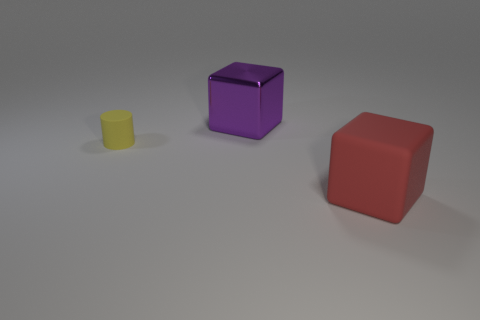Add 1 large metallic objects. How many objects exist? 4 Subtract all cylinders. How many objects are left? 2 Add 2 small yellow rubber things. How many small yellow rubber things are left? 3 Add 1 cyan matte objects. How many cyan matte objects exist? 1 Subtract 1 purple blocks. How many objects are left? 2 Subtract all small cylinders. Subtract all yellow cylinders. How many objects are left? 1 